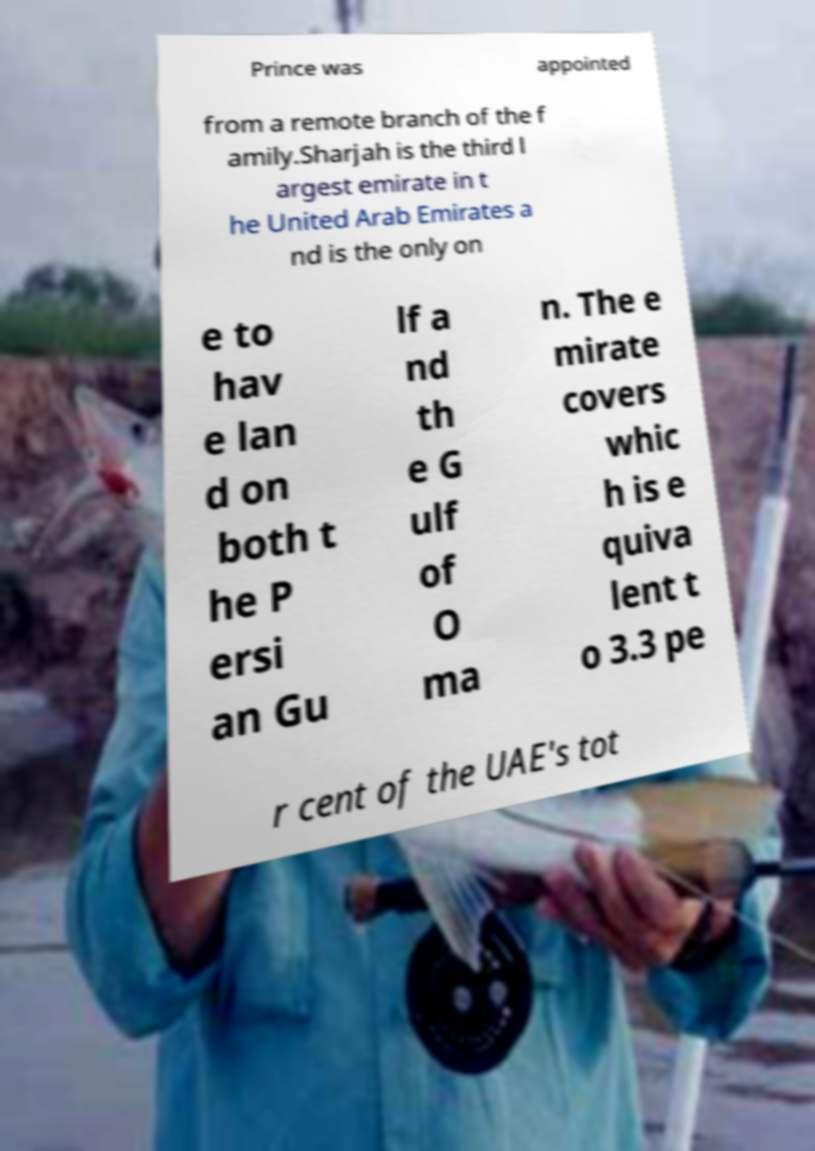Can you read and provide the text displayed in the image?This photo seems to have some interesting text. Can you extract and type it out for me? Prince was appointed from a remote branch of the f amily.Sharjah is the third l argest emirate in t he United Arab Emirates a nd is the only on e to hav e lan d on both t he P ersi an Gu lf a nd th e G ulf of O ma n. The e mirate covers whic h is e quiva lent t o 3.3 pe r cent of the UAE's tot 